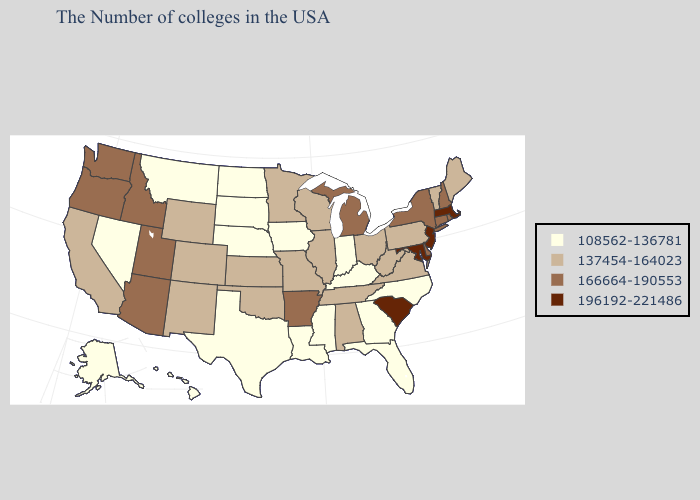Name the states that have a value in the range 166664-190553?
Give a very brief answer. Rhode Island, New Hampshire, Connecticut, New York, Delaware, Michigan, Arkansas, Utah, Arizona, Idaho, Washington, Oregon. Does the first symbol in the legend represent the smallest category?
Keep it brief. Yes. Does Wyoming have the highest value in the West?
Be succinct. No. Does Hawaii have the lowest value in the West?
Short answer required. Yes. What is the highest value in states that border Utah?
Quick response, please. 166664-190553. Does South Carolina have a higher value than Maryland?
Keep it brief. No. Is the legend a continuous bar?
Answer briefly. No. What is the value of Colorado?
Give a very brief answer. 137454-164023. What is the lowest value in the South?
Quick response, please. 108562-136781. Name the states that have a value in the range 166664-190553?
Be succinct. Rhode Island, New Hampshire, Connecticut, New York, Delaware, Michigan, Arkansas, Utah, Arizona, Idaho, Washington, Oregon. What is the lowest value in the South?
Give a very brief answer. 108562-136781. Does Maryland have the highest value in the USA?
Short answer required. Yes. What is the highest value in the Northeast ?
Write a very short answer. 196192-221486. Does Pennsylvania have the highest value in the USA?
Write a very short answer. No. 